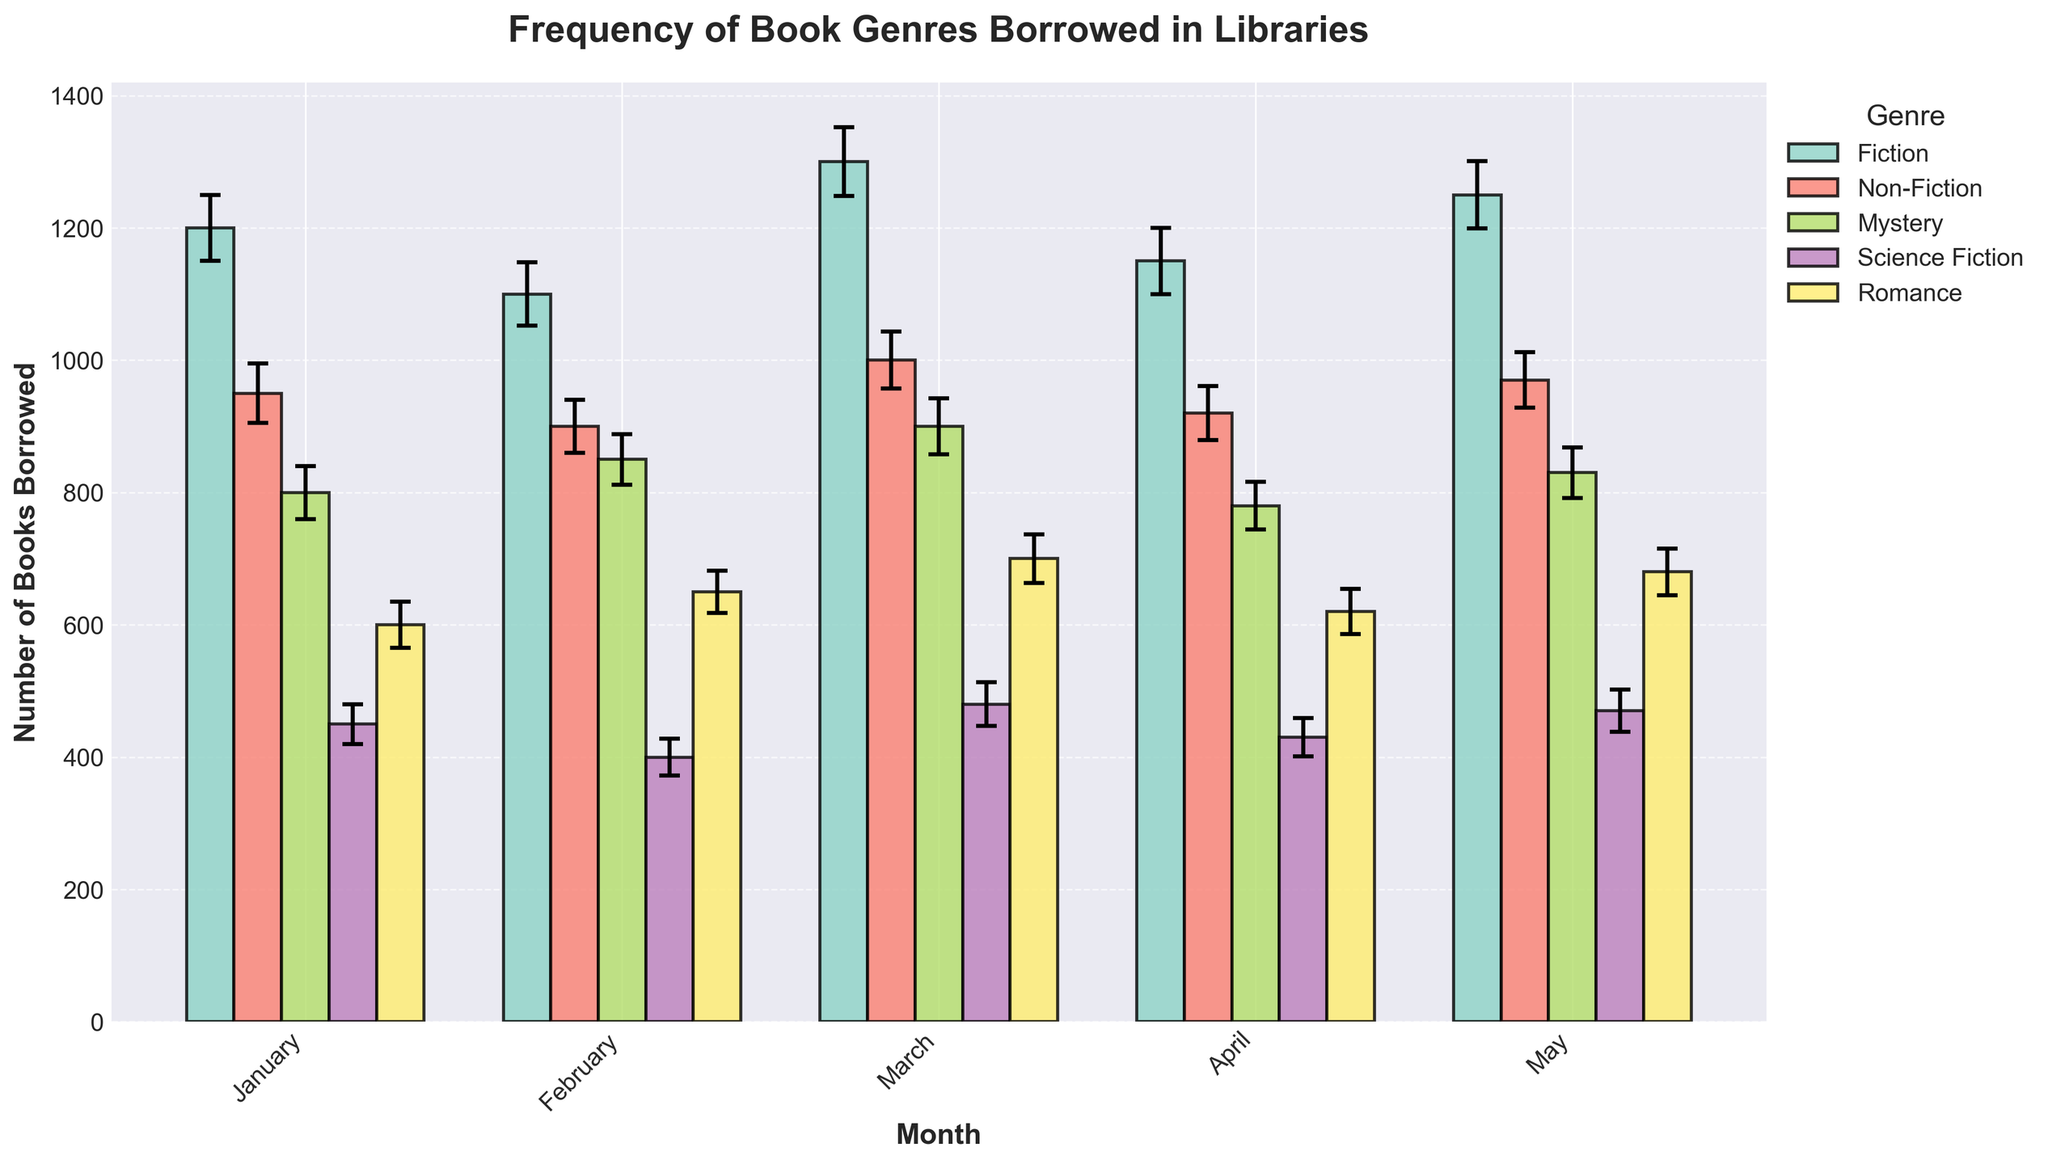What is the title of the chart? The title of the chart is displayed at the top of the figure in bold and large font. It summarizes the main content of the chart.
Answer: Frequency of Book Genres Borrowed in Libraries Which month had the highest number of fiction books borrowed? By examining the height of the bars for the Fiction genre across all months, we can see that March has the tallest bar, indicating the highest number of books borrowed.
Answer: March How many romance books were borrowed in February? Locate the Romance bars in the chart and find the one corresponding to February by looking at the x-axis labels.
Answer: 650 What's the approximate error margin for Mystery books borrowed in May? Find the Mystery bar for May and look at the error bar extending above and below it. The vertical line above the bar indicates the error margin.
Answer: 38 Which genre had the smallest error margin in January? Compare the lengths of the error bars for each genre in January. The shortest error bar corresponds to Science Fiction.
Answer: Science Fiction What is the difference in the number of Science Fiction books borrowed between January and March? Subtract the number of Science Fiction books borrowed in January (450) from those borrowed in March (480).
Answer: 30 What is the combined total of Non-Fiction books borrowed in March and April? Add the number of Non-Fiction books borrowed in March (1000) and April (920).
Answer: 1920 Which genre has more books borrowed on average over the five months: Mystery or Romance? Calculate the average for both genres over the five months and compare them. Average for Mystery: (800+850+900+780+830)/5 = 832. Average for Romance: (600+650+700+620+680)/5 = 650.
Answer: Mystery Which month shows the largest error margin for any genre? Find the maximum error margin across all months and genres. March's Fiction has the highest error margin of 52.
Answer: March Between Fiction and Non-Fiction, which genre showed a more consistent borrowing rate over the five months? Consistency can be judged by the size of the error margins. Fiction has larger error margins compared to Non-Fiction, indicating more variability. Non-Fiction showed a more consistent borrowing rate.
Answer: Non-Fiction 